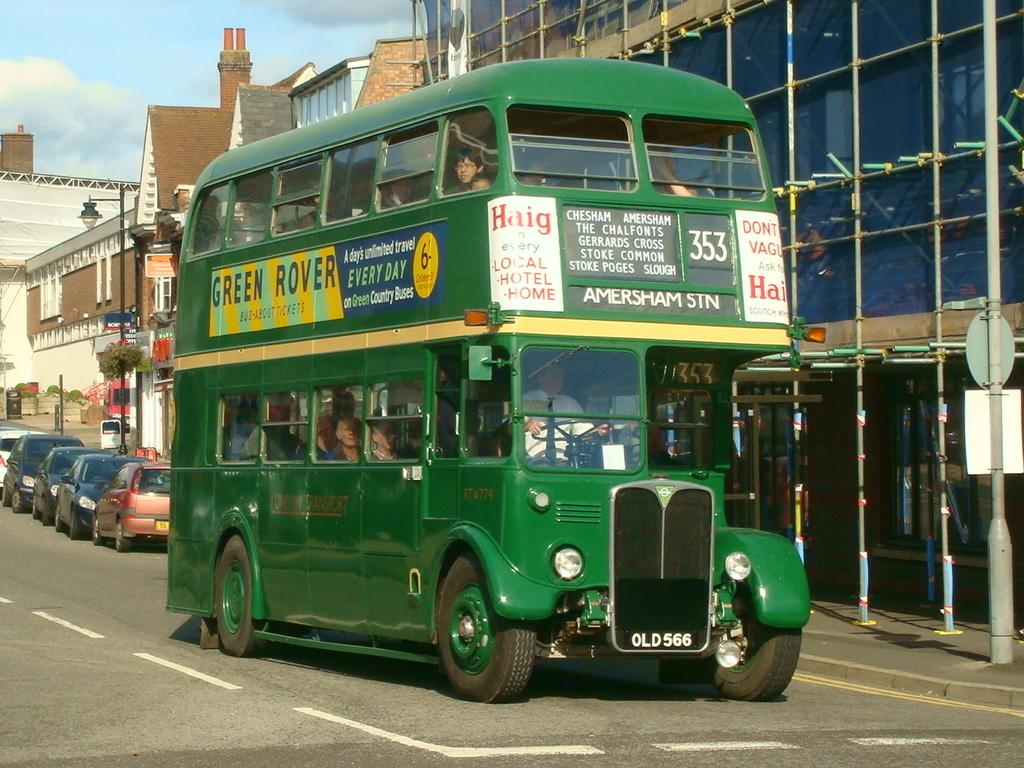What can be seen on the road in the image? There are vehicles on the road in the image. Are there any people visible in the vehicles? Yes, there are persons inside a vehicle in the image. What can be seen in the background of the image? There are buildings, poles, boards, lights, plants, and the sky visible in the background. Can you describe the sky in the image? The sky is visible in the background, and clouds are present in the sky. What type of cable is hanging from the buildings in the image? There is no cable hanging from the buildings in the image. What list is being referenced in the image? There is no list present in the image. Can you hear a bell ringing in the image? There is no auditory information in the image, so it is impossible to determine if a bell is ringing. 